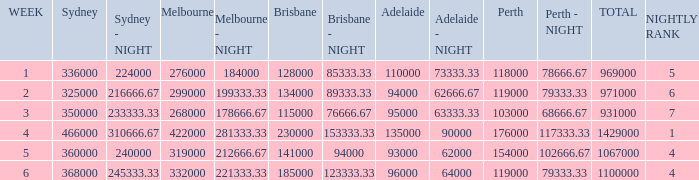Give me the full table as a dictionary. {'header': ['WEEK', 'Sydney', 'Sydney - NIGHT', 'Melbourne', 'Melbourne - NIGHT', 'Brisbane', 'Brisbane - NIGHT', 'Adelaide', 'Adelaide - NIGHT', 'Perth', 'Perth - NIGHT', 'TOTAL', 'NIGHTLY RANK'], 'rows': [['1', '336000', '224000', '276000', '184000', '128000', '85333.33', '110000', '73333.33', '118000', '78666.67', '969000', '5'], ['2', '325000', '216666.67', '299000', '199333.33', '134000', '89333.33', '94000', '62666.67', '119000', '79333.33', '971000', '6'], ['3', '350000', '233333.33', '268000', '178666.67', '115000', '76666.67', '95000', '63333.33', '103000', '68666.67', '931000', '7'], ['4', '466000', '310666.67', '422000', '281333.33', '230000', '153333.33', '135000', '90000', '176000', '117333.33', '1429000', '1'], ['5', '360000', '240000', '319000', '212666.67', '141000', '94000', '93000', '62000', '154000', '102666.67', '1067000', '4'], ['6', '368000', '245333.33', '332000', '221333.33', '185000', '123333.33', '96000', '64000', '119000', '79333.33', '1100000', '4']]} What was the rating in Brisbane the week it was 276000 in Melbourne?  128000.0. 